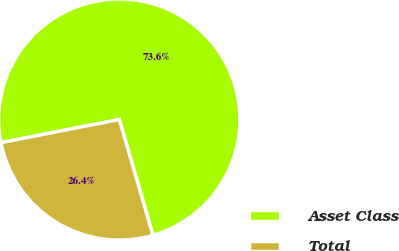<chart> <loc_0><loc_0><loc_500><loc_500><pie_chart><fcel>Asset Class<fcel>Total<nl><fcel>73.56%<fcel>26.44%<nl></chart> 